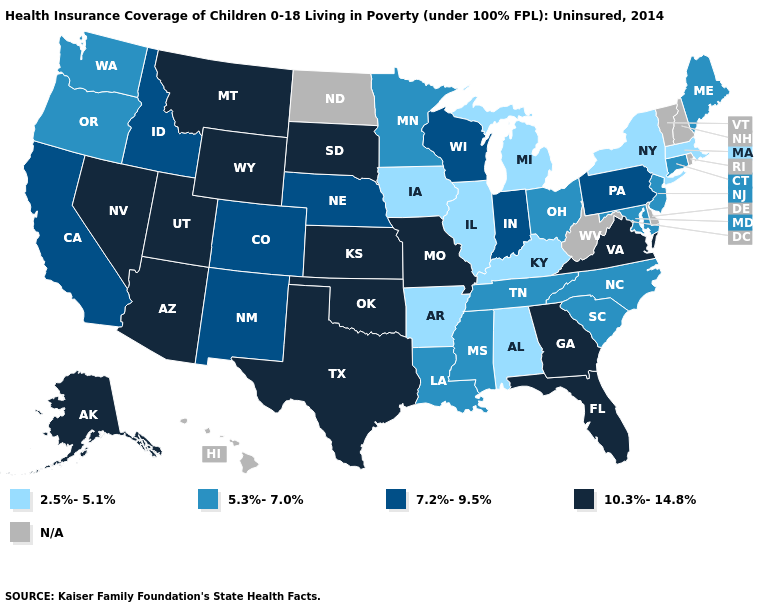What is the value of Wyoming?
Answer briefly. 10.3%-14.8%. What is the value of Tennessee?
Answer briefly. 5.3%-7.0%. What is the lowest value in the USA?
Give a very brief answer. 2.5%-5.1%. Which states have the lowest value in the West?
Quick response, please. Oregon, Washington. What is the value of Texas?
Answer briefly. 10.3%-14.8%. Name the states that have a value in the range 2.5%-5.1%?
Be succinct. Alabama, Arkansas, Illinois, Iowa, Kentucky, Massachusetts, Michigan, New York. What is the highest value in the USA?
Quick response, please. 10.3%-14.8%. Name the states that have a value in the range 7.2%-9.5%?
Short answer required. California, Colorado, Idaho, Indiana, Nebraska, New Mexico, Pennsylvania, Wisconsin. Among the states that border Rhode Island , which have the highest value?
Give a very brief answer. Connecticut. Name the states that have a value in the range N/A?
Be succinct. Delaware, Hawaii, New Hampshire, North Dakota, Rhode Island, Vermont, West Virginia. Name the states that have a value in the range N/A?
Concise answer only. Delaware, Hawaii, New Hampshire, North Dakota, Rhode Island, Vermont, West Virginia. What is the value of Wisconsin?
Be succinct. 7.2%-9.5%. 